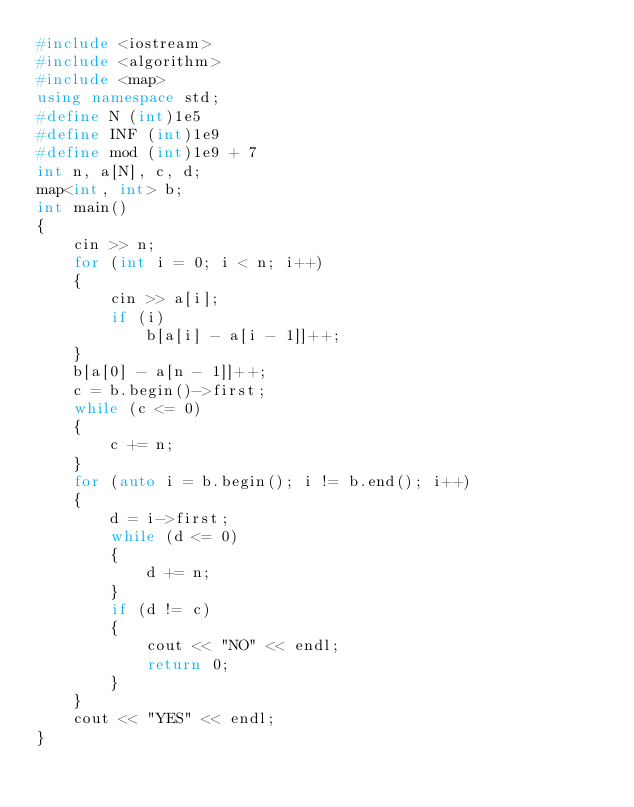Convert code to text. <code><loc_0><loc_0><loc_500><loc_500><_C++_>#include <iostream>
#include <algorithm>
#include <map>
using namespace std;
#define N (int)1e5
#define INF (int)1e9
#define mod (int)1e9 + 7
int n, a[N], c, d;
map<int, int> b;
int main()
{
	cin >> n;
	for (int i = 0; i < n; i++)
	{
		cin >> a[i];
		if (i)
			b[a[i] - a[i - 1]]++;
	}
	b[a[0] - a[n - 1]]++;
	c = b.begin()->first;
	while (c <= 0)
	{
		c += n;
	}
	for (auto i = b.begin(); i != b.end(); i++)
	{
		d = i->first;
		while (d <= 0)
		{
			d += n;
		}
		if (d != c)
		{
			cout << "NO" << endl;
			return 0;
		}
	}
	cout << "YES" << endl;
}</code> 